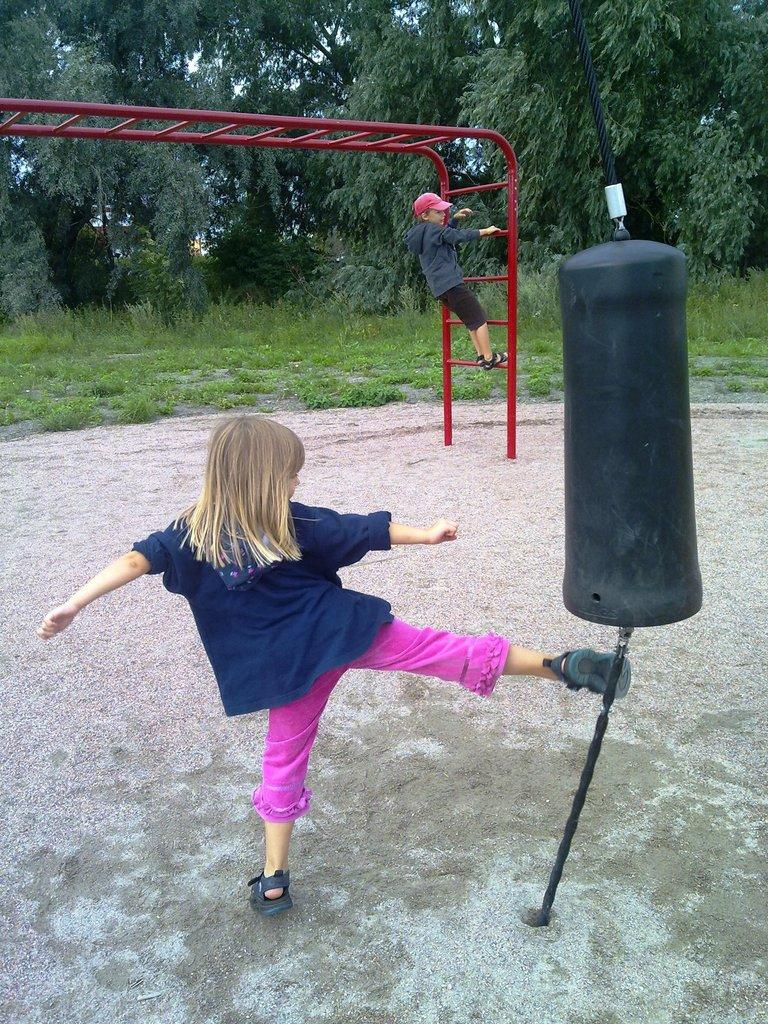Who is the main subject in the image? There is a small girl in the image. What is the girl doing in the image? The girl is kicking at a target pole. Are there any other people in the image? Yes, there is a boy in the image. What is the boy doing in the image? The boy is climbing a ladder. What can be seen in the background of the image? There are trees visible in the image. What is the name of the pet dog that is playing with the girl in the image? There is no pet dog present in the image; the girl is kicking at a target pole. 